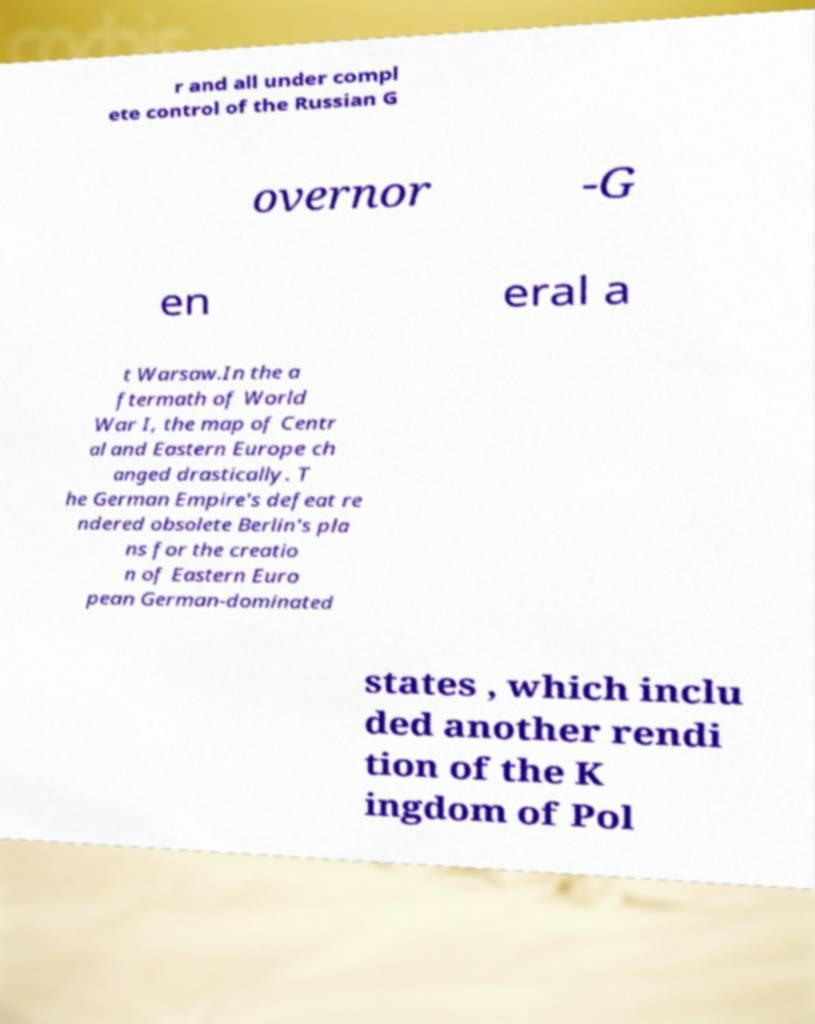Can you read and provide the text displayed in the image?This photo seems to have some interesting text. Can you extract and type it out for me? r and all under compl ete control of the Russian G overnor -G en eral a t Warsaw.In the a ftermath of World War I, the map of Centr al and Eastern Europe ch anged drastically. T he German Empire's defeat re ndered obsolete Berlin's pla ns for the creatio n of Eastern Euro pean German-dominated states , which inclu ded another rendi tion of the K ingdom of Pol 